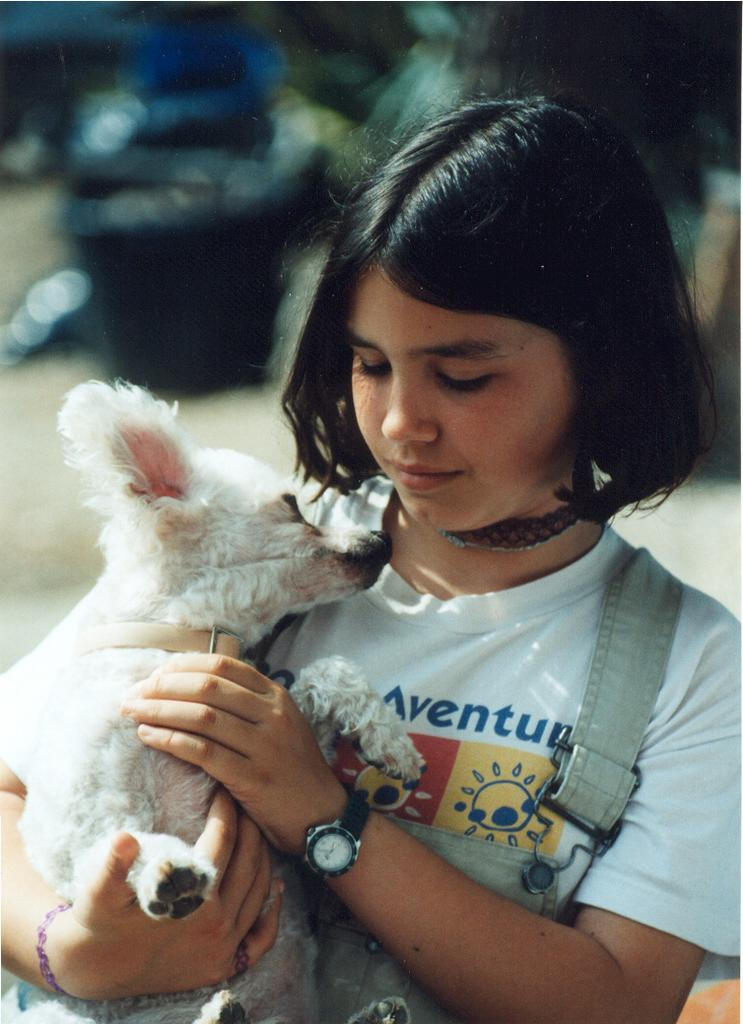Who is the main subject in the image? There is a girl in the image. What is the girl holding in the image? The girl is holding a puppy. Can you describe the girl's hair in the image? The girl has short hair, and it is black. What can be said about the background of the image? The background of the image is blurry. What type of glue is the girl using to attach the representative to the lawyer in the image? There is no glue, representative, or lawyer present in the image. 